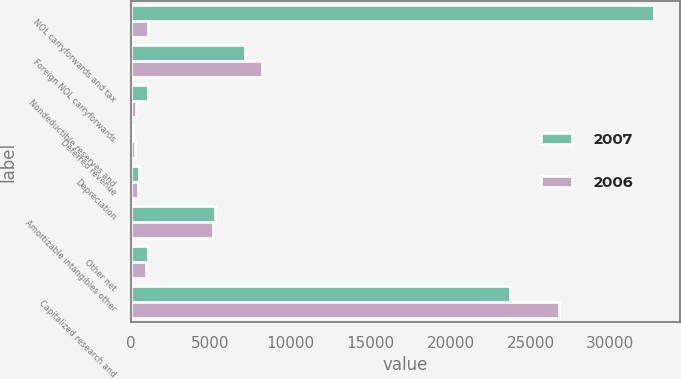Convert chart. <chart><loc_0><loc_0><loc_500><loc_500><stacked_bar_chart><ecel><fcel>NOL carryforwards and tax<fcel>Foreign NOL carryforwards<fcel>Nondeductible reserves and<fcel>Deferred revenue<fcel>Depreciation<fcel>Amortizable intangibles other<fcel>Other net<fcel>Capitalized research and<nl><fcel>2007<fcel>32700<fcel>7119<fcel>1070<fcel>132<fcel>505<fcel>5284<fcel>1079<fcel>23721<nl><fcel>2006<fcel>1079<fcel>8237<fcel>338<fcel>263<fcel>489<fcel>5180<fcel>959<fcel>26801<nl></chart> 